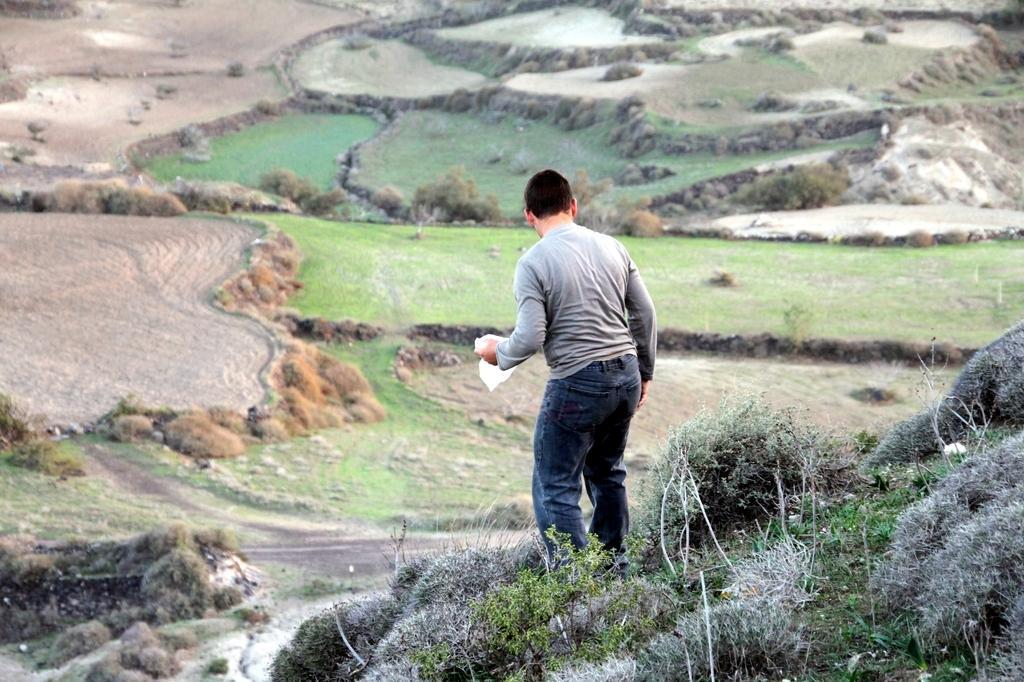Can you describe this image briefly? In this image there is a person standing on the land having few plants on it. Before him there is land having some grass, plants, rocks are on it. 